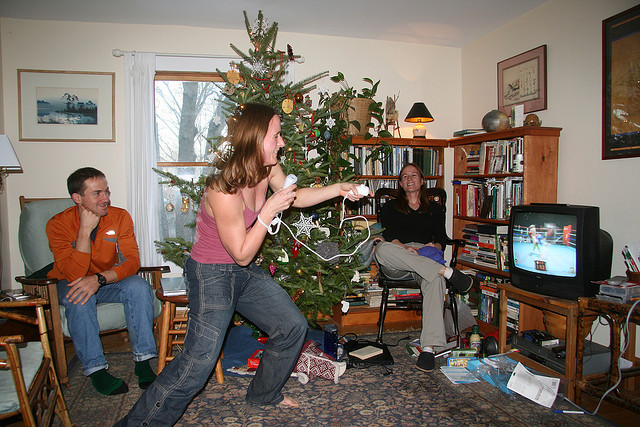<image>What kind of shoes is she wearing? The woman is not wearing any shoes. What kind of shoes is she wearing? I don't know what kind of shoes she is wearing. It seems like she is not wearing any shoes. 